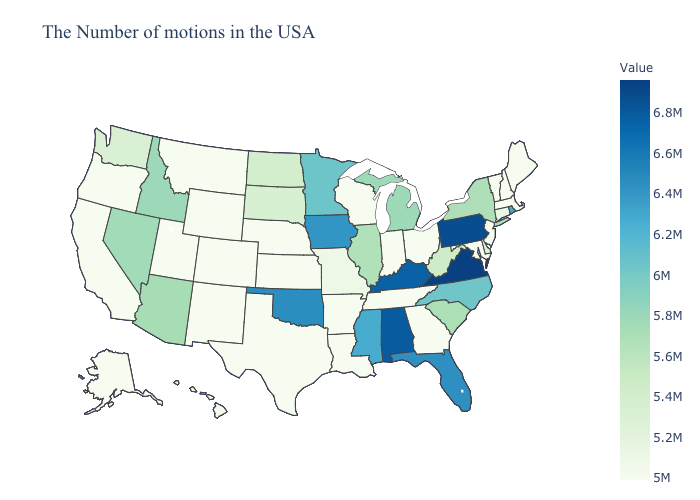Does Florida have the lowest value in the South?
Concise answer only. No. Does Illinois have a lower value than Hawaii?
Concise answer only. No. Which states have the lowest value in the MidWest?
Concise answer only. Ohio, Indiana, Wisconsin, Kansas, Nebraska. Among the states that border Massachusetts , which have the highest value?
Short answer required. Rhode Island. Among the states that border Arkansas , does Oklahoma have the highest value?
Short answer required. Yes. Does Idaho have the highest value in the West?
Concise answer only. Yes. Does Kansas have the lowest value in the USA?
Be succinct. Yes. 